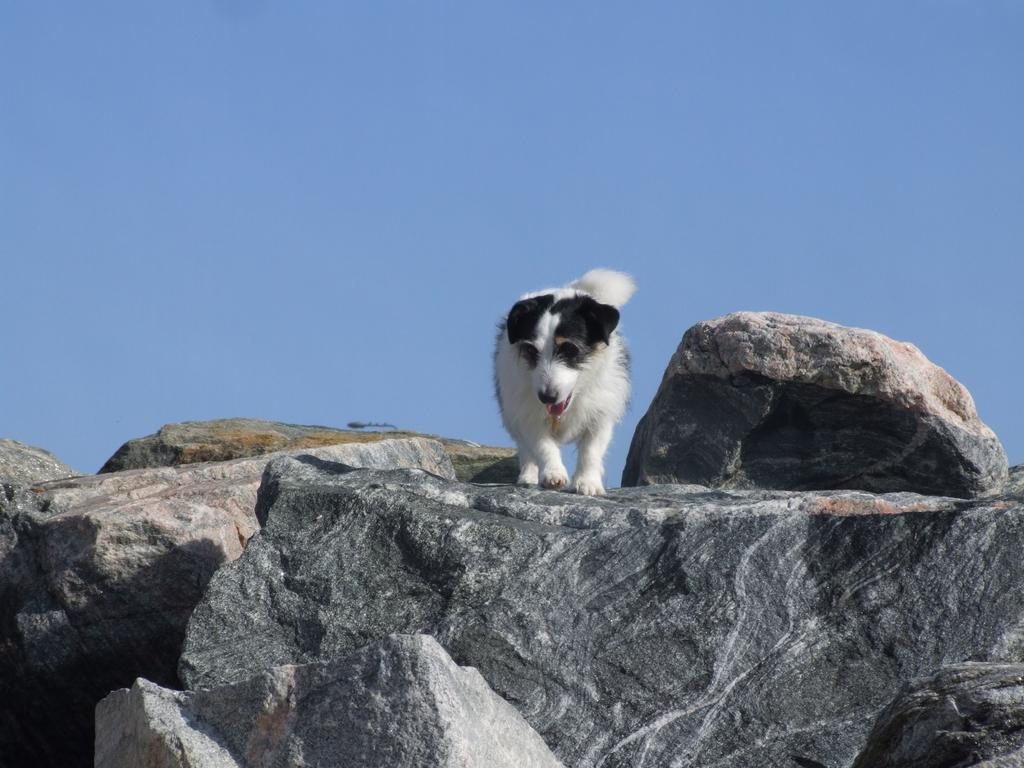What animal is present in the image? There is a dog in the image. Where is the dog located? The dog is standing on mountain rocks. What can be seen at the top of the image? There is sky visible at the top of the image. What type of record is being played in the image? There is no record present in the image; it features a dog standing on mountain rocks. Can you tell me how many people are in the club in the image? There is no club or people present in the image; it features a dog standing on mountain rocks. 